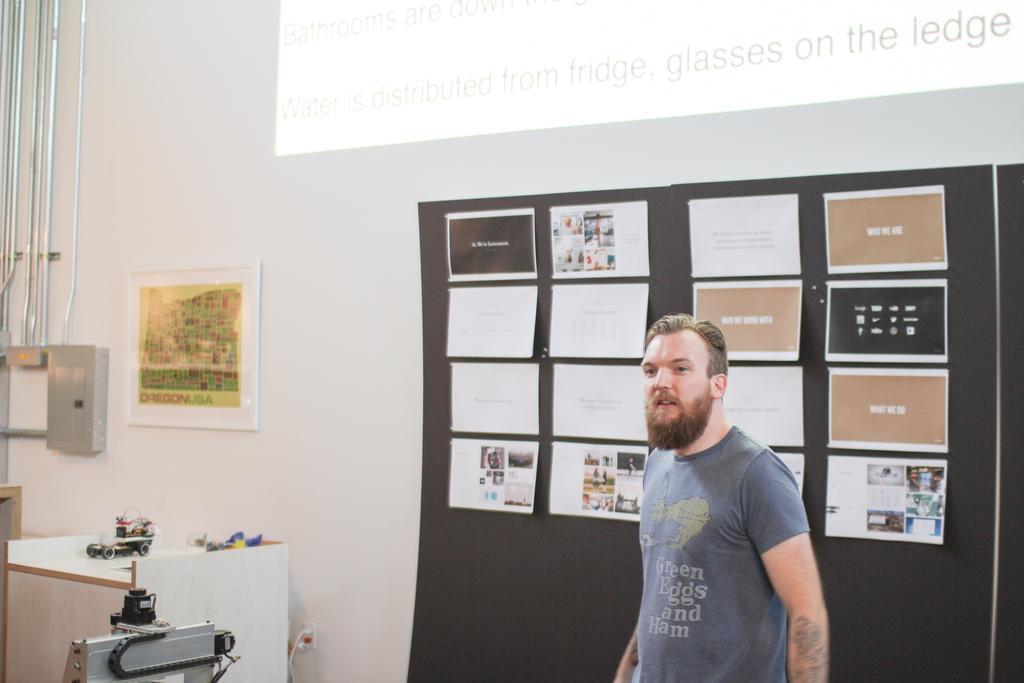How would you summarize this image in a sentence or two? On the right side, there is a person in a gray color t-shirt, smiling and standing. On the left side, there is an object. In the background, there is a screen, there is a toy vehicle on the wooden table, there is a photo frame on a white wall and there are pipes and an object attached to the white wall. 